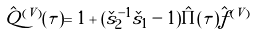<formula> <loc_0><loc_0><loc_500><loc_500>\hat { Q } ^ { ( V ) } ( \tau ) = 1 + ( \check { s } _ { 2 } ^ { - 1 } \check { s } _ { 1 } - 1 ) \hat { \Pi } ( \tau ) \hat { f } ^ { ( V ) }</formula> 